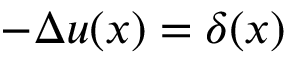Convert formula to latex. <formula><loc_0><loc_0><loc_500><loc_500>- \Delta u ( x ) = \delta ( x )</formula> 